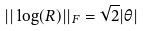<formula> <loc_0><loc_0><loc_500><loc_500>| | \log ( R ) | | _ { F } = \sqrt { 2 } | \theta |</formula> 